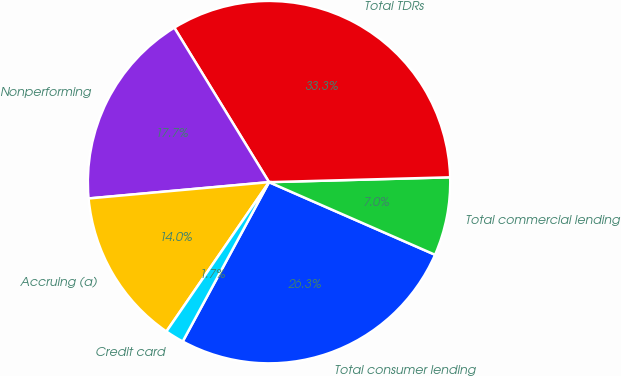Convert chart. <chart><loc_0><loc_0><loc_500><loc_500><pie_chart><fcel>Total consumer lending<fcel>Total commercial lending<fcel>Total TDRs<fcel>Nonperforming<fcel>Accruing (a)<fcel>Credit card<nl><fcel>26.34%<fcel>6.99%<fcel>33.33%<fcel>17.68%<fcel>13.98%<fcel>1.68%<nl></chart> 